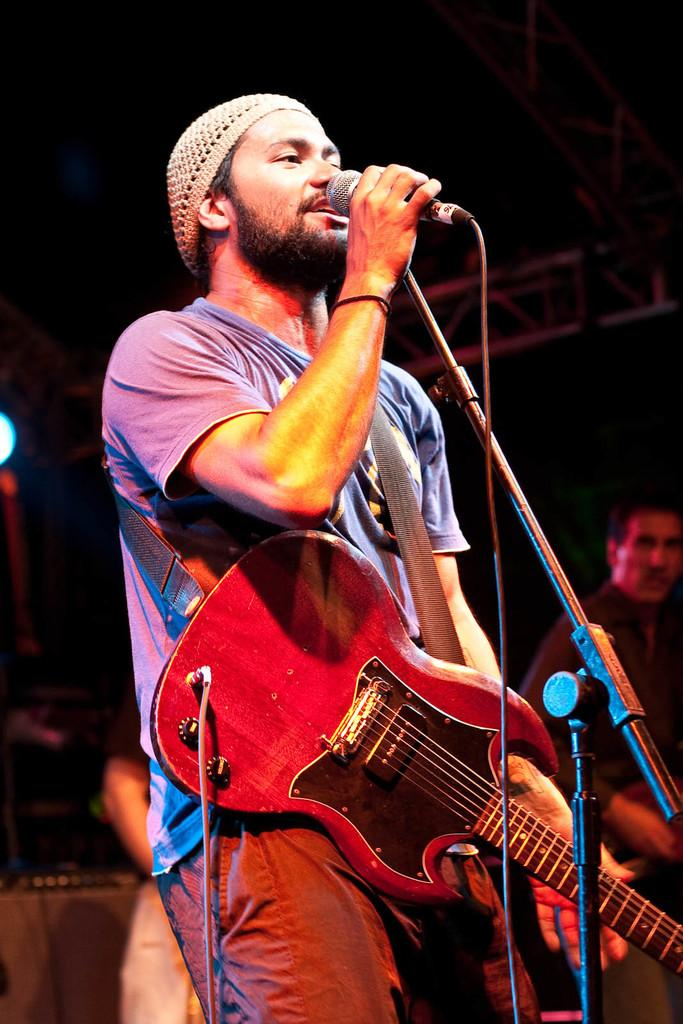What is the main subject of the image? The main subject of the image is a man. What is the man wearing in the image? The man is wearing a guitar in the image. What is the man holding in the image? The man is holding a microphone in the image. What is the man doing in the image? The man is singing in the image. Can you describe the other person in the image? There is another person standing far from the man in the image. What type of picture is the man holding in the image? There is no picture present in the image; the man is holding a microphone. What religion does the man belong to in the image? There is no information about the man's religion in the image. 